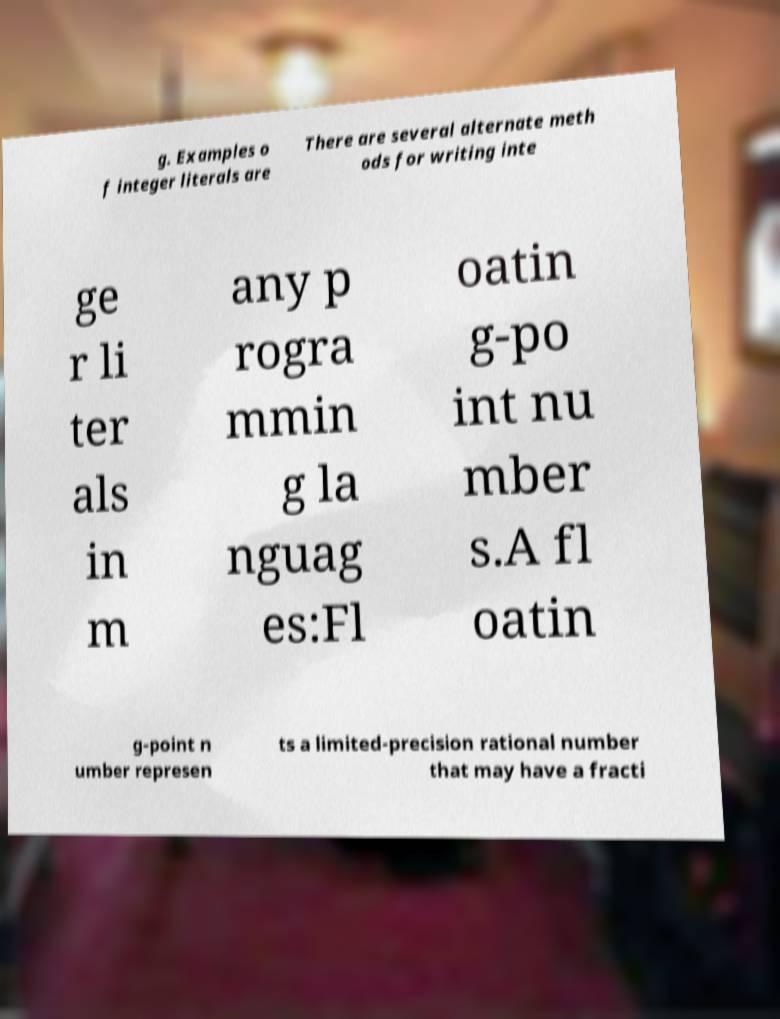Please read and relay the text visible in this image. What does it say? g. Examples o f integer literals are There are several alternate meth ods for writing inte ge r li ter als in m any p rogra mmin g la nguag es:Fl oatin g-po int nu mber s.A fl oatin g-point n umber represen ts a limited-precision rational number that may have a fracti 